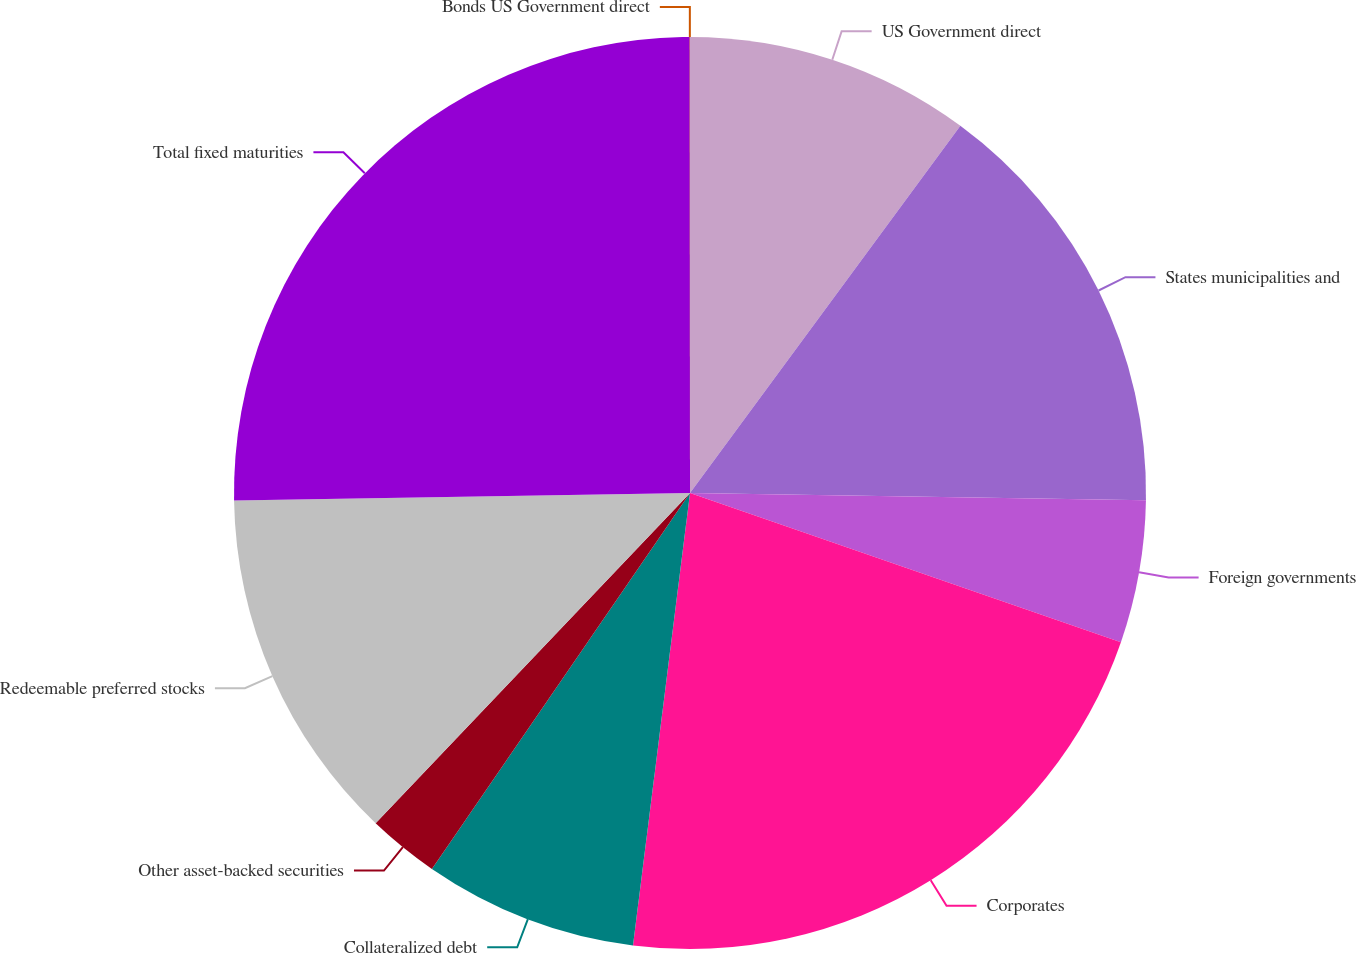Convert chart to OTSL. <chart><loc_0><loc_0><loc_500><loc_500><pie_chart><fcel>US Government direct<fcel>States municipalities and<fcel>Foreign governments<fcel>Corporates<fcel>Collateralized debt<fcel>Other asset-backed securities<fcel>Redeemable preferred stocks<fcel>Total fixed maturities<fcel>Bonds US Government direct<nl><fcel>10.1%<fcel>15.15%<fcel>5.05%<fcel>21.69%<fcel>7.58%<fcel>2.53%<fcel>12.63%<fcel>25.25%<fcel>0.01%<nl></chart> 